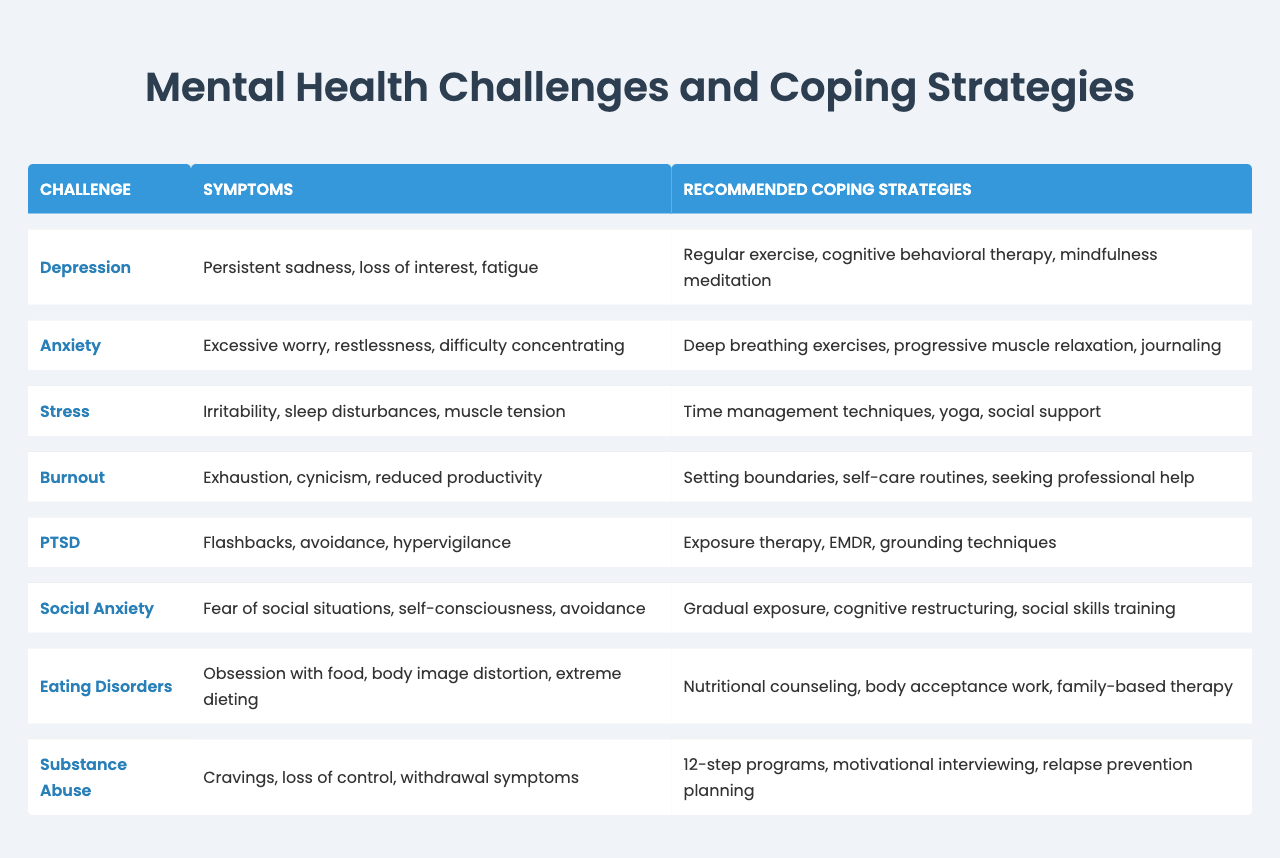What is the main symptom of burnout? The main symptom of burnout listed in the table is exhaustion.
Answer: exhaustion Which mental health challenge has the symptom of hypervigilance? The challenge associated with hypervigilance is PTSD.
Answer: PTSD How many coping strategies are recommended for anxiety? The table lists three coping strategies for anxiety: deep breathing exercises, progressive muscle relaxation, and journaling.
Answer: three Do eating disorders include cravings as a symptom? No, cravings are not listed as a symptom of eating disorders in the table; they are associated with substance abuse.
Answer: no What is the relationship between depression and mindfulness meditation? Mindfulness meditation is one of the recommended coping strategies for managing depression, indicating it may help alleviate its symptoms.
Answer: mindfulness meditation helps alleviate depression Which mental health challenge has the highest number of listed coping strategies? All challenges have three strategies listed, except for substance abuse, which mentions three, resulting in an even distribution.
Answer: all have three strategies If someone experiences persistent sadness and fatigue, which coping strategy should they consider first? They should consider regular exercise first, as it is listed as a recommended coping strategy for depression, which includes those symptoms.
Answer: regular exercise What are the two specific symptoms of social anxiety mentioned in the table? The two specific symptoms of social anxiety are fear of social situations and self-consciousness.
Answer: fear of social situations and self-consciousness Which two mental health challenges involve feelings of avoidance? The challenges involving feelings of avoidance are PTSD and social anxiety.
Answer: PTSD and social anxiety Is yoga a coping strategy for managing stress? Yes, yoga is listed as one of the recommended coping strategies for managing stress.
Answer: yes 